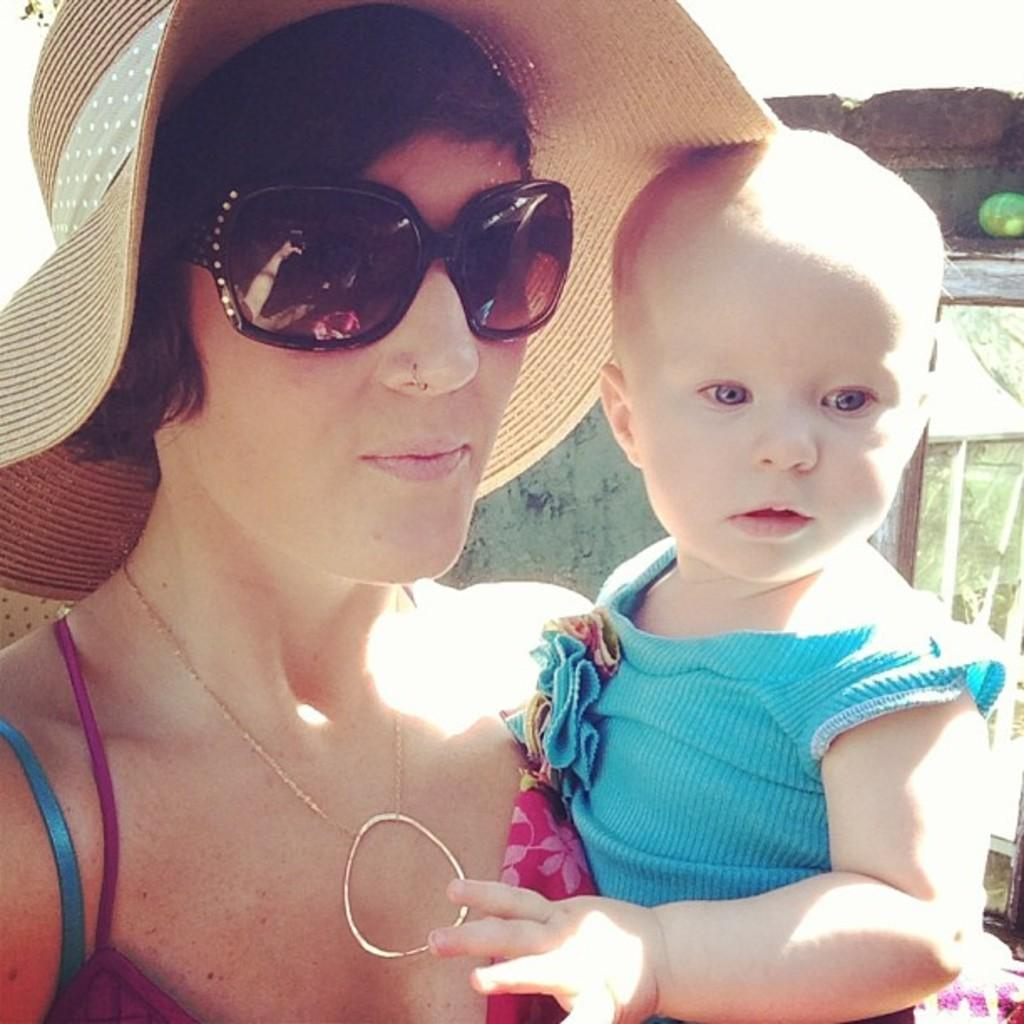Who is present in the image? There is a woman and a baby in the image. What is the woman wearing on her head? The woman is wearing a hat in the image. What type of eyewear is the woman wearing? The woman is wearing goggles in the image. What can be seen in the background of the image? There is a wall in the background of the image. What type of dock can be seen in the image? There is no dock present in the image. How does the woman compare to the zinc in the image? There is no zinc present in the image, so it cannot be compared to the woman. 